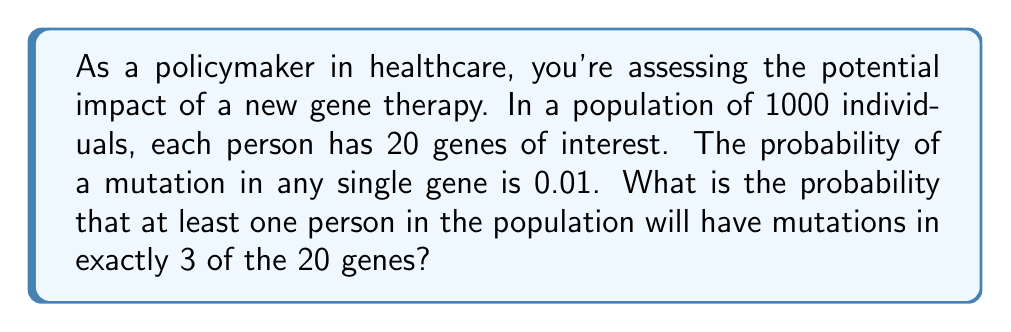Solve this math problem. To solve this problem, we'll use combinatorics and probability theory. Let's break it down step by step:

1) First, we need to calculate the probability of one person having mutations in exactly 3 of the 20 genes.

   a) The probability of a mutation in a single gene is 0.01, so the probability of no mutation is 0.99.
   
   b) We can use the binomial probability formula:
      
      $P(\text{3 mutations}) = \binom{20}{3} (0.01)^3 (0.99)^{17}$

   c) Calculate:
      $$\binom{20}{3} = \frac{20!}{3!(20-3)!} = \frac{20!}{3!17!} = 1140$$
      
      $P(\text{3 mutations}) = 1140 \cdot (0.01)^3 \cdot (0.99)^{17} \approx 0.001425$

2) Now, we need to find the probability that at least one person in the population of 1000 has exactly 3 mutations.

   a) It's easier to calculate the probability that no one has exactly 3 mutations and then subtract from 1.
   
   b) The probability that one person doesn't have exactly 3 mutations is $1 - 0.001425 = 0.998575$
   
   c) For all 1000 people to not have exactly 3 mutations:
      
      $P(\text{no one has 3 mutations}) = (0.998575)^{1000}$

   d) Therefore, the probability that at least one person has exactly 3 mutations is:
      
      $P(\text{at least one person has 3 mutations}) = 1 - (0.998575)^{1000}$

3) Calculate the final result:
   
   $1 - (0.998575)^{1000} \approx 0.7611$
Answer: The probability that at least one person in the population will have mutations in exactly 3 of the 20 genes is approximately 0.7611 or 76.11%. 